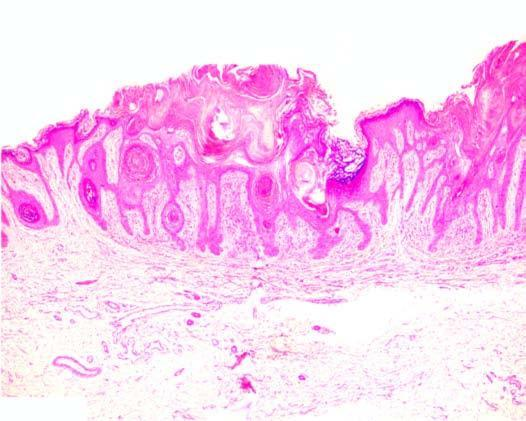s peripheral blood in itp in a straight line from the normal uninvolved epidermis?
Answer the question using a single word or phrase. No 